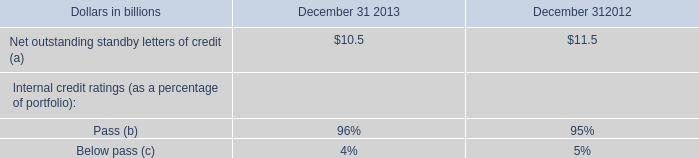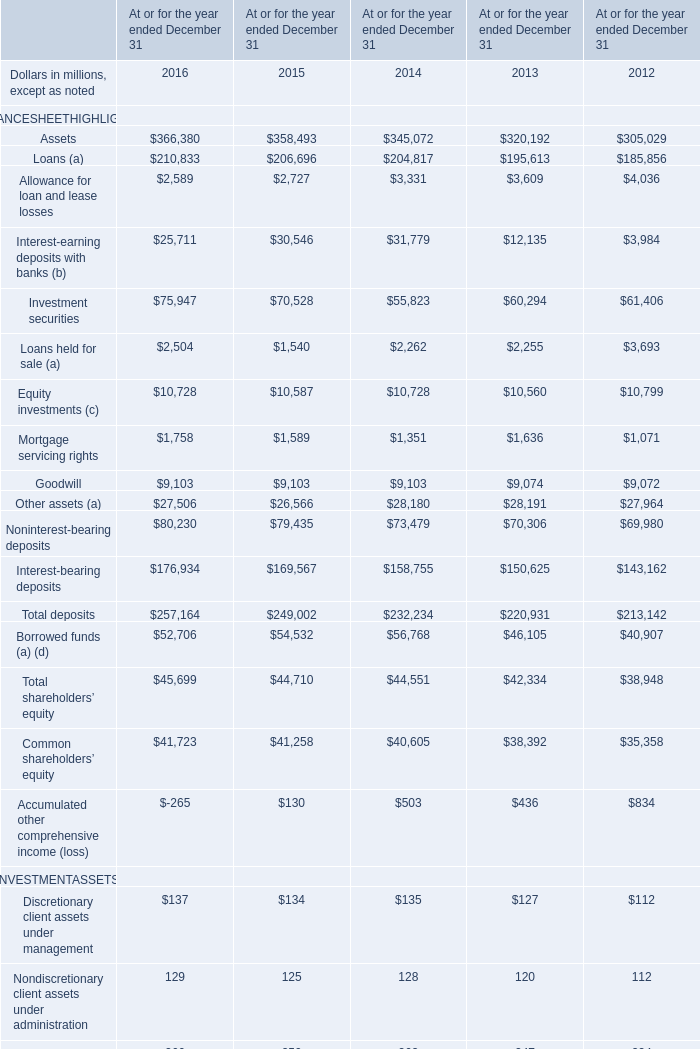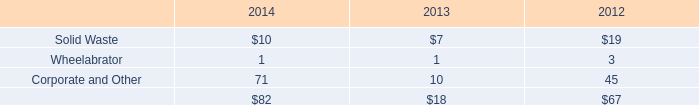What will the value of Investment securities on December 31 be like in 2017 if it develops with the same increasing rate as current? (in million) 
Computations: (75947 * (1 + ((75947 - 70528) / 70528)))
Answer: 81782.36741. 